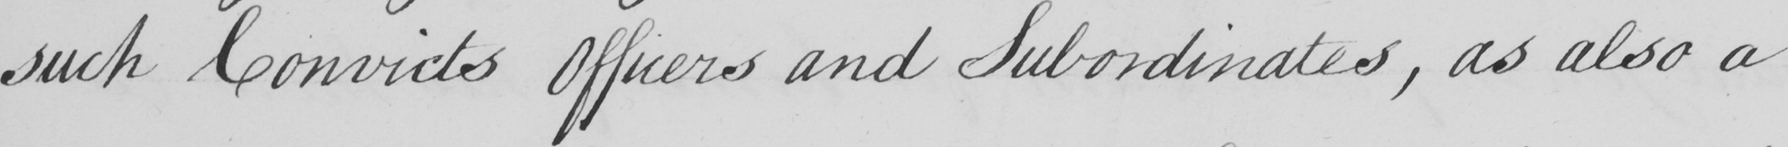Can you read and transcribe this handwriting? such convicts Officers and Subordinates , as also a 